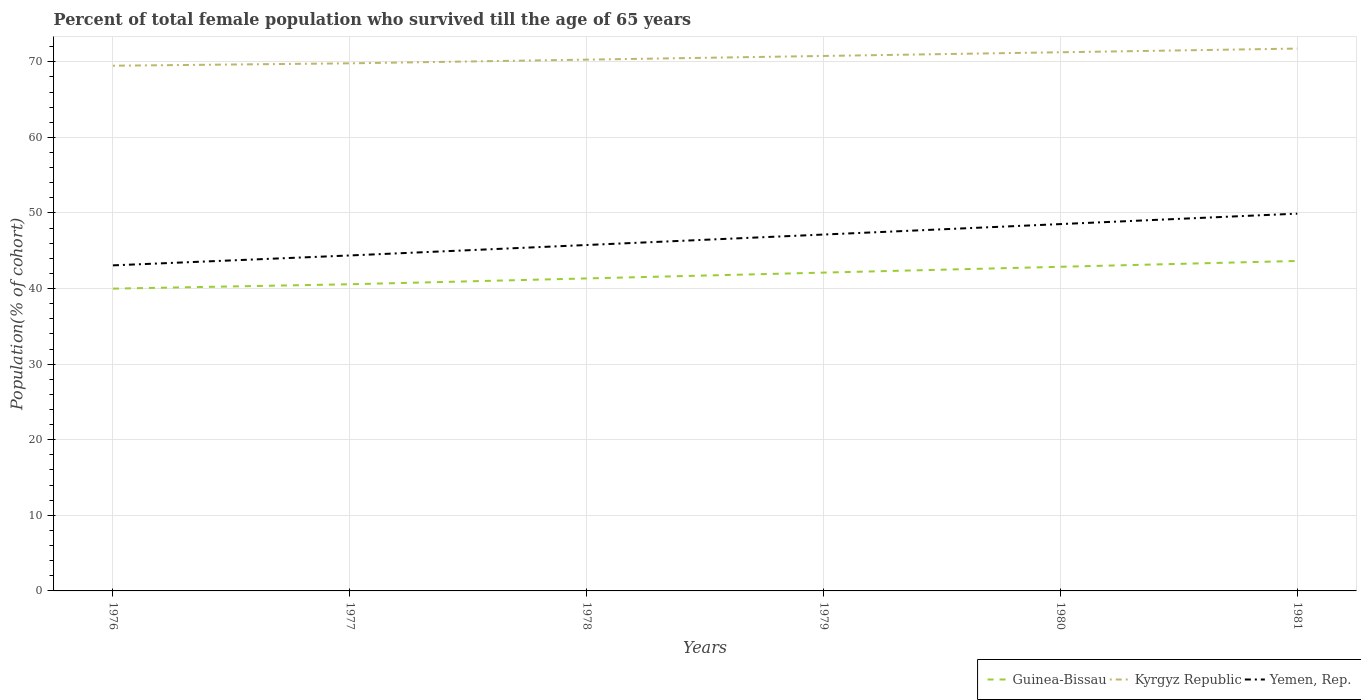Does the line corresponding to Kyrgyz Republic intersect with the line corresponding to Guinea-Bissau?
Offer a very short reply. No. Is the number of lines equal to the number of legend labels?
Offer a terse response. Yes. Across all years, what is the maximum percentage of total female population who survived till the age of 65 years in Kyrgyz Republic?
Give a very brief answer. 69.48. In which year was the percentage of total female population who survived till the age of 65 years in Kyrgyz Republic maximum?
Your answer should be very brief. 1976. What is the total percentage of total female population who survived till the age of 65 years in Kyrgyz Republic in the graph?
Your answer should be very brief. -1.46. What is the difference between the highest and the second highest percentage of total female population who survived till the age of 65 years in Yemen, Rep.?
Make the answer very short. 6.84. How many lines are there?
Provide a succinct answer. 3. How many years are there in the graph?
Offer a very short reply. 6. What is the difference between two consecutive major ticks on the Y-axis?
Your answer should be very brief. 10. Does the graph contain grids?
Offer a terse response. Yes. How many legend labels are there?
Offer a very short reply. 3. What is the title of the graph?
Make the answer very short. Percent of total female population who survived till the age of 65 years. Does "Low & middle income" appear as one of the legend labels in the graph?
Make the answer very short. No. What is the label or title of the Y-axis?
Offer a terse response. Population(% of cohort). What is the Population(% of cohort) of Guinea-Bissau in 1976?
Make the answer very short. 39.99. What is the Population(% of cohort) in Kyrgyz Republic in 1976?
Ensure brevity in your answer.  69.48. What is the Population(% of cohort) of Yemen, Rep. in 1976?
Your response must be concise. 43.07. What is the Population(% of cohort) of Guinea-Bissau in 1977?
Offer a very short reply. 40.57. What is the Population(% of cohort) of Kyrgyz Republic in 1977?
Your response must be concise. 69.8. What is the Population(% of cohort) of Yemen, Rep. in 1977?
Offer a terse response. 44.38. What is the Population(% of cohort) of Guinea-Bissau in 1978?
Keep it short and to the point. 41.34. What is the Population(% of cohort) in Kyrgyz Republic in 1978?
Give a very brief answer. 70.29. What is the Population(% of cohort) of Yemen, Rep. in 1978?
Offer a terse response. 45.76. What is the Population(% of cohort) in Guinea-Bissau in 1979?
Your answer should be very brief. 42.11. What is the Population(% of cohort) in Kyrgyz Republic in 1979?
Ensure brevity in your answer.  70.77. What is the Population(% of cohort) in Yemen, Rep. in 1979?
Give a very brief answer. 47.15. What is the Population(% of cohort) in Guinea-Bissau in 1980?
Give a very brief answer. 42.88. What is the Population(% of cohort) in Kyrgyz Republic in 1980?
Offer a terse response. 71.26. What is the Population(% of cohort) of Yemen, Rep. in 1980?
Offer a terse response. 48.53. What is the Population(% of cohort) in Guinea-Bissau in 1981?
Provide a succinct answer. 43.65. What is the Population(% of cohort) in Kyrgyz Republic in 1981?
Provide a short and direct response. 71.75. What is the Population(% of cohort) of Yemen, Rep. in 1981?
Your response must be concise. 49.91. Across all years, what is the maximum Population(% of cohort) of Guinea-Bissau?
Offer a terse response. 43.65. Across all years, what is the maximum Population(% of cohort) of Kyrgyz Republic?
Your answer should be very brief. 71.75. Across all years, what is the maximum Population(% of cohort) of Yemen, Rep.?
Your answer should be very brief. 49.91. Across all years, what is the minimum Population(% of cohort) of Guinea-Bissau?
Provide a succinct answer. 39.99. Across all years, what is the minimum Population(% of cohort) of Kyrgyz Republic?
Give a very brief answer. 69.48. Across all years, what is the minimum Population(% of cohort) of Yemen, Rep.?
Make the answer very short. 43.07. What is the total Population(% of cohort) in Guinea-Bissau in the graph?
Provide a succinct answer. 250.54. What is the total Population(% of cohort) in Kyrgyz Republic in the graph?
Provide a succinct answer. 423.35. What is the total Population(% of cohort) in Yemen, Rep. in the graph?
Ensure brevity in your answer.  278.8. What is the difference between the Population(% of cohort) of Guinea-Bissau in 1976 and that in 1977?
Ensure brevity in your answer.  -0.58. What is the difference between the Population(% of cohort) of Kyrgyz Republic in 1976 and that in 1977?
Offer a terse response. -0.32. What is the difference between the Population(% of cohort) in Yemen, Rep. in 1976 and that in 1977?
Make the answer very short. -1.31. What is the difference between the Population(% of cohort) in Guinea-Bissau in 1976 and that in 1978?
Your answer should be very brief. -1.35. What is the difference between the Population(% of cohort) in Kyrgyz Republic in 1976 and that in 1978?
Provide a short and direct response. -0.8. What is the difference between the Population(% of cohort) of Yemen, Rep. in 1976 and that in 1978?
Provide a short and direct response. -2.69. What is the difference between the Population(% of cohort) of Guinea-Bissau in 1976 and that in 1979?
Your answer should be compact. -2.12. What is the difference between the Population(% of cohort) of Kyrgyz Republic in 1976 and that in 1979?
Give a very brief answer. -1.29. What is the difference between the Population(% of cohort) in Yemen, Rep. in 1976 and that in 1979?
Ensure brevity in your answer.  -4.08. What is the difference between the Population(% of cohort) of Guinea-Bissau in 1976 and that in 1980?
Give a very brief answer. -2.89. What is the difference between the Population(% of cohort) of Kyrgyz Republic in 1976 and that in 1980?
Provide a succinct answer. -1.78. What is the difference between the Population(% of cohort) in Yemen, Rep. in 1976 and that in 1980?
Your answer should be very brief. -5.46. What is the difference between the Population(% of cohort) of Guinea-Bissau in 1976 and that in 1981?
Offer a very short reply. -3.66. What is the difference between the Population(% of cohort) of Kyrgyz Republic in 1976 and that in 1981?
Offer a terse response. -2.27. What is the difference between the Population(% of cohort) of Yemen, Rep. in 1976 and that in 1981?
Offer a very short reply. -6.84. What is the difference between the Population(% of cohort) of Guinea-Bissau in 1977 and that in 1978?
Your response must be concise. -0.77. What is the difference between the Population(% of cohort) of Kyrgyz Republic in 1977 and that in 1978?
Offer a very short reply. -0.49. What is the difference between the Population(% of cohort) of Yemen, Rep. in 1977 and that in 1978?
Provide a succinct answer. -1.38. What is the difference between the Population(% of cohort) in Guinea-Bissau in 1977 and that in 1979?
Provide a succinct answer. -1.54. What is the difference between the Population(% of cohort) in Kyrgyz Republic in 1977 and that in 1979?
Your response must be concise. -0.98. What is the difference between the Population(% of cohort) in Yemen, Rep. in 1977 and that in 1979?
Your answer should be very brief. -2.77. What is the difference between the Population(% of cohort) in Guinea-Bissau in 1977 and that in 1980?
Give a very brief answer. -2.31. What is the difference between the Population(% of cohort) of Kyrgyz Republic in 1977 and that in 1980?
Offer a terse response. -1.46. What is the difference between the Population(% of cohort) in Yemen, Rep. in 1977 and that in 1980?
Provide a short and direct response. -4.15. What is the difference between the Population(% of cohort) of Guinea-Bissau in 1977 and that in 1981?
Offer a terse response. -3.08. What is the difference between the Population(% of cohort) in Kyrgyz Republic in 1977 and that in 1981?
Your answer should be compact. -1.95. What is the difference between the Population(% of cohort) in Yemen, Rep. in 1977 and that in 1981?
Provide a succinct answer. -5.53. What is the difference between the Population(% of cohort) in Guinea-Bissau in 1978 and that in 1979?
Give a very brief answer. -0.77. What is the difference between the Population(% of cohort) of Kyrgyz Republic in 1978 and that in 1979?
Offer a terse response. -0.49. What is the difference between the Population(% of cohort) of Yemen, Rep. in 1978 and that in 1979?
Keep it short and to the point. -1.38. What is the difference between the Population(% of cohort) of Guinea-Bissau in 1978 and that in 1980?
Your answer should be very brief. -1.54. What is the difference between the Population(% of cohort) in Kyrgyz Republic in 1978 and that in 1980?
Provide a short and direct response. -0.98. What is the difference between the Population(% of cohort) in Yemen, Rep. in 1978 and that in 1980?
Offer a terse response. -2.77. What is the difference between the Population(% of cohort) in Guinea-Bissau in 1978 and that in 1981?
Give a very brief answer. -2.31. What is the difference between the Population(% of cohort) in Kyrgyz Republic in 1978 and that in 1981?
Ensure brevity in your answer.  -1.46. What is the difference between the Population(% of cohort) in Yemen, Rep. in 1978 and that in 1981?
Keep it short and to the point. -4.15. What is the difference between the Population(% of cohort) of Guinea-Bissau in 1979 and that in 1980?
Your response must be concise. -0.77. What is the difference between the Population(% of cohort) of Kyrgyz Republic in 1979 and that in 1980?
Your answer should be compact. -0.49. What is the difference between the Population(% of cohort) of Yemen, Rep. in 1979 and that in 1980?
Provide a short and direct response. -1.38. What is the difference between the Population(% of cohort) of Guinea-Bissau in 1979 and that in 1981?
Provide a succinct answer. -1.54. What is the difference between the Population(% of cohort) in Kyrgyz Republic in 1979 and that in 1981?
Your answer should be very brief. -0.98. What is the difference between the Population(% of cohort) of Yemen, Rep. in 1979 and that in 1981?
Provide a succinct answer. -2.77. What is the difference between the Population(% of cohort) of Guinea-Bissau in 1980 and that in 1981?
Keep it short and to the point. -0.77. What is the difference between the Population(% of cohort) in Kyrgyz Republic in 1980 and that in 1981?
Offer a terse response. -0.49. What is the difference between the Population(% of cohort) of Yemen, Rep. in 1980 and that in 1981?
Provide a short and direct response. -1.38. What is the difference between the Population(% of cohort) in Guinea-Bissau in 1976 and the Population(% of cohort) in Kyrgyz Republic in 1977?
Offer a very short reply. -29.81. What is the difference between the Population(% of cohort) of Guinea-Bissau in 1976 and the Population(% of cohort) of Yemen, Rep. in 1977?
Offer a terse response. -4.39. What is the difference between the Population(% of cohort) of Kyrgyz Republic in 1976 and the Population(% of cohort) of Yemen, Rep. in 1977?
Ensure brevity in your answer.  25.1. What is the difference between the Population(% of cohort) in Guinea-Bissau in 1976 and the Population(% of cohort) in Kyrgyz Republic in 1978?
Offer a very short reply. -30.3. What is the difference between the Population(% of cohort) in Guinea-Bissau in 1976 and the Population(% of cohort) in Yemen, Rep. in 1978?
Ensure brevity in your answer.  -5.77. What is the difference between the Population(% of cohort) in Kyrgyz Republic in 1976 and the Population(% of cohort) in Yemen, Rep. in 1978?
Give a very brief answer. 23.72. What is the difference between the Population(% of cohort) of Guinea-Bissau in 1976 and the Population(% of cohort) of Kyrgyz Republic in 1979?
Keep it short and to the point. -30.78. What is the difference between the Population(% of cohort) in Guinea-Bissau in 1976 and the Population(% of cohort) in Yemen, Rep. in 1979?
Your answer should be compact. -7.16. What is the difference between the Population(% of cohort) in Kyrgyz Republic in 1976 and the Population(% of cohort) in Yemen, Rep. in 1979?
Offer a terse response. 22.33. What is the difference between the Population(% of cohort) of Guinea-Bissau in 1976 and the Population(% of cohort) of Kyrgyz Republic in 1980?
Provide a short and direct response. -31.27. What is the difference between the Population(% of cohort) of Guinea-Bissau in 1976 and the Population(% of cohort) of Yemen, Rep. in 1980?
Your answer should be compact. -8.54. What is the difference between the Population(% of cohort) of Kyrgyz Republic in 1976 and the Population(% of cohort) of Yemen, Rep. in 1980?
Provide a short and direct response. 20.95. What is the difference between the Population(% of cohort) of Guinea-Bissau in 1976 and the Population(% of cohort) of Kyrgyz Republic in 1981?
Give a very brief answer. -31.76. What is the difference between the Population(% of cohort) of Guinea-Bissau in 1976 and the Population(% of cohort) of Yemen, Rep. in 1981?
Your answer should be compact. -9.92. What is the difference between the Population(% of cohort) in Kyrgyz Republic in 1976 and the Population(% of cohort) in Yemen, Rep. in 1981?
Your answer should be compact. 19.57. What is the difference between the Population(% of cohort) of Guinea-Bissau in 1977 and the Population(% of cohort) of Kyrgyz Republic in 1978?
Keep it short and to the point. -29.72. What is the difference between the Population(% of cohort) in Guinea-Bissau in 1977 and the Population(% of cohort) in Yemen, Rep. in 1978?
Keep it short and to the point. -5.19. What is the difference between the Population(% of cohort) of Kyrgyz Republic in 1977 and the Population(% of cohort) of Yemen, Rep. in 1978?
Keep it short and to the point. 24.03. What is the difference between the Population(% of cohort) of Guinea-Bissau in 1977 and the Population(% of cohort) of Kyrgyz Republic in 1979?
Provide a short and direct response. -30.2. What is the difference between the Population(% of cohort) in Guinea-Bissau in 1977 and the Population(% of cohort) in Yemen, Rep. in 1979?
Give a very brief answer. -6.58. What is the difference between the Population(% of cohort) of Kyrgyz Republic in 1977 and the Population(% of cohort) of Yemen, Rep. in 1979?
Offer a terse response. 22.65. What is the difference between the Population(% of cohort) in Guinea-Bissau in 1977 and the Population(% of cohort) in Kyrgyz Republic in 1980?
Offer a terse response. -30.69. What is the difference between the Population(% of cohort) of Guinea-Bissau in 1977 and the Population(% of cohort) of Yemen, Rep. in 1980?
Your response must be concise. -7.96. What is the difference between the Population(% of cohort) of Kyrgyz Republic in 1977 and the Population(% of cohort) of Yemen, Rep. in 1980?
Provide a short and direct response. 21.27. What is the difference between the Population(% of cohort) in Guinea-Bissau in 1977 and the Population(% of cohort) in Kyrgyz Republic in 1981?
Offer a very short reply. -31.18. What is the difference between the Population(% of cohort) of Guinea-Bissau in 1977 and the Population(% of cohort) of Yemen, Rep. in 1981?
Provide a short and direct response. -9.34. What is the difference between the Population(% of cohort) of Kyrgyz Republic in 1977 and the Population(% of cohort) of Yemen, Rep. in 1981?
Keep it short and to the point. 19.89. What is the difference between the Population(% of cohort) of Guinea-Bissau in 1978 and the Population(% of cohort) of Kyrgyz Republic in 1979?
Offer a very short reply. -29.43. What is the difference between the Population(% of cohort) of Guinea-Bissau in 1978 and the Population(% of cohort) of Yemen, Rep. in 1979?
Make the answer very short. -5.81. What is the difference between the Population(% of cohort) in Kyrgyz Republic in 1978 and the Population(% of cohort) in Yemen, Rep. in 1979?
Keep it short and to the point. 23.14. What is the difference between the Population(% of cohort) of Guinea-Bissau in 1978 and the Population(% of cohort) of Kyrgyz Republic in 1980?
Give a very brief answer. -29.92. What is the difference between the Population(% of cohort) of Guinea-Bissau in 1978 and the Population(% of cohort) of Yemen, Rep. in 1980?
Offer a very short reply. -7.19. What is the difference between the Population(% of cohort) in Kyrgyz Republic in 1978 and the Population(% of cohort) in Yemen, Rep. in 1980?
Keep it short and to the point. 21.76. What is the difference between the Population(% of cohort) in Guinea-Bissau in 1978 and the Population(% of cohort) in Kyrgyz Republic in 1981?
Provide a short and direct response. -30.41. What is the difference between the Population(% of cohort) of Guinea-Bissau in 1978 and the Population(% of cohort) of Yemen, Rep. in 1981?
Your response must be concise. -8.57. What is the difference between the Population(% of cohort) of Kyrgyz Republic in 1978 and the Population(% of cohort) of Yemen, Rep. in 1981?
Offer a terse response. 20.37. What is the difference between the Population(% of cohort) in Guinea-Bissau in 1979 and the Population(% of cohort) in Kyrgyz Republic in 1980?
Provide a short and direct response. -29.15. What is the difference between the Population(% of cohort) in Guinea-Bissau in 1979 and the Population(% of cohort) in Yemen, Rep. in 1980?
Keep it short and to the point. -6.42. What is the difference between the Population(% of cohort) in Kyrgyz Republic in 1979 and the Population(% of cohort) in Yemen, Rep. in 1980?
Your answer should be very brief. 22.24. What is the difference between the Population(% of cohort) of Guinea-Bissau in 1979 and the Population(% of cohort) of Kyrgyz Republic in 1981?
Make the answer very short. -29.64. What is the difference between the Population(% of cohort) in Guinea-Bissau in 1979 and the Population(% of cohort) in Yemen, Rep. in 1981?
Your answer should be compact. -7.8. What is the difference between the Population(% of cohort) of Kyrgyz Republic in 1979 and the Population(% of cohort) of Yemen, Rep. in 1981?
Your response must be concise. 20.86. What is the difference between the Population(% of cohort) of Guinea-Bissau in 1980 and the Population(% of cohort) of Kyrgyz Republic in 1981?
Ensure brevity in your answer.  -28.87. What is the difference between the Population(% of cohort) of Guinea-Bissau in 1980 and the Population(% of cohort) of Yemen, Rep. in 1981?
Make the answer very short. -7.03. What is the difference between the Population(% of cohort) of Kyrgyz Republic in 1980 and the Population(% of cohort) of Yemen, Rep. in 1981?
Make the answer very short. 21.35. What is the average Population(% of cohort) in Guinea-Bissau per year?
Ensure brevity in your answer.  41.76. What is the average Population(% of cohort) of Kyrgyz Republic per year?
Keep it short and to the point. 70.56. What is the average Population(% of cohort) of Yemen, Rep. per year?
Your response must be concise. 46.47. In the year 1976, what is the difference between the Population(% of cohort) in Guinea-Bissau and Population(% of cohort) in Kyrgyz Republic?
Provide a short and direct response. -29.49. In the year 1976, what is the difference between the Population(% of cohort) of Guinea-Bissau and Population(% of cohort) of Yemen, Rep.?
Ensure brevity in your answer.  -3.08. In the year 1976, what is the difference between the Population(% of cohort) in Kyrgyz Republic and Population(% of cohort) in Yemen, Rep.?
Your answer should be very brief. 26.41. In the year 1977, what is the difference between the Population(% of cohort) in Guinea-Bissau and Population(% of cohort) in Kyrgyz Republic?
Keep it short and to the point. -29.23. In the year 1977, what is the difference between the Population(% of cohort) of Guinea-Bissau and Population(% of cohort) of Yemen, Rep.?
Make the answer very short. -3.81. In the year 1977, what is the difference between the Population(% of cohort) of Kyrgyz Republic and Population(% of cohort) of Yemen, Rep.?
Keep it short and to the point. 25.42. In the year 1978, what is the difference between the Population(% of cohort) of Guinea-Bissau and Population(% of cohort) of Kyrgyz Republic?
Offer a terse response. -28.95. In the year 1978, what is the difference between the Population(% of cohort) of Guinea-Bissau and Population(% of cohort) of Yemen, Rep.?
Offer a very short reply. -4.42. In the year 1978, what is the difference between the Population(% of cohort) in Kyrgyz Republic and Population(% of cohort) in Yemen, Rep.?
Your answer should be very brief. 24.52. In the year 1979, what is the difference between the Population(% of cohort) of Guinea-Bissau and Population(% of cohort) of Kyrgyz Republic?
Give a very brief answer. -28.66. In the year 1979, what is the difference between the Population(% of cohort) of Guinea-Bissau and Population(% of cohort) of Yemen, Rep.?
Your answer should be compact. -5.04. In the year 1979, what is the difference between the Population(% of cohort) of Kyrgyz Republic and Population(% of cohort) of Yemen, Rep.?
Offer a very short reply. 23.63. In the year 1980, what is the difference between the Population(% of cohort) of Guinea-Bissau and Population(% of cohort) of Kyrgyz Republic?
Your answer should be very brief. -28.38. In the year 1980, what is the difference between the Population(% of cohort) of Guinea-Bissau and Population(% of cohort) of Yemen, Rep.?
Provide a succinct answer. -5.65. In the year 1980, what is the difference between the Population(% of cohort) of Kyrgyz Republic and Population(% of cohort) of Yemen, Rep.?
Ensure brevity in your answer.  22.73. In the year 1981, what is the difference between the Population(% of cohort) in Guinea-Bissau and Population(% of cohort) in Kyrgyz Republic?
Ensure brevity in your answer.  -28.1. In the year 1981, what is the difference between the Population(% of cohort) of Guinea-Bissau and Population(% of cohort) of Yemen, Rep.?
Make the answer very short. -6.26. In the year 1981, what is the difference between the Population(% of cohort) in Kyrgyz Republic and Population(% of cohort) in Yemen, Rep.?
Your answer should be very brief. 21.84. What is the ratio of the Population(% of cohort) in Guinea-Bissau in 1976 to that in 1977?
Keep it short and to the point. 0.99. What is the ratio of the Population(% of cohort) of Yemen, Rep. in 1976 to that in 1977?
Give a very brief answer. 0.97. What is the ratio of the Population(% of cohort) of Guinea-Bissau in 1976 to that in 1978?
Offer a very short reply. 0.97. What is the ratio of the Population(% of cohort) in Yemen, Rep. in 1976 to that in 1978?
Your response must be concise. 0.94. What is the ratio of the Population(% of cohort) of Guinea-Bissau in 1976 to that in 1979?
Your answer should be very brief. 0.95. What is the ratio of the Population(% of cohort) of Kyrgyz Republic in 1976 to that in 1979?
Your response must be concise. 0.98. What is the ratio of the Population(% of cohort) in Yemen, Rep. in 1976 to that in 1979?
Provide a succinct answer. 0.91. What is the ratio of the Population(% of cohort) in Guinea-Bissau in 1976 to that in 1980?
Provide a short and direct response. 0.93. What is the ratio of the Population(% of cohort) of Kyrgyz Republic in 1976 to that in 1980?
Your answer should be very brief. 0.97. What is the ratio of the Population(% of cohort) of Yemen, Rep. in 1976 to that in 1980?
Keep it short and to the point. 0.89. What is the ratio of the Population(% of cohort) in Guinea-Bissau in 1976 to that in 1981?
Give a very brief answer. 0.92. What is the ratio of the Population(% of cohort) in Kyrgyz Republic in 1976 to that in 1981?
Your response must be concise. 0.97. What is the ratio of the Population(% of cohort) in Yemen, Rep. in 1976 to that in 1981?
Your answer should be very brief. 0.86. What is the ratio of the Population(% of cohort) of Guinea-Bissau in 1977 to that in 1978?
Your response must be concise. 0.98. What is the ratio of the Population(% of cohort) in Yemen, Rep. in 1977 to that in 1978?
Keep it short and to the point. 0.97. What is the ratio of the Population(% of cohort) in Guinea-Bissau in 1977 to that in 1979?
Give a very brief answer. 0.96. What is the ratio of the Population(% of cohort) of Kyrgyz Republic in 1977 to that in 1979?
Give a very brief answer. 0.99. What is the ratio of the Population(% of cohort) of Yemen, Rep. in 1977 to that in 1979?
Give a very brief answer. 0.94. What is the ratio of the Population(% of cohort) of Guinea-Bissau in 1977 to that in 1980?
Offer a terse response. 0.95. What is the ratio of the Population(% of cohort) in Kyrgyz Republic in 1977 to that in 1980?
Provide a short and direct response. 0.98. What is the ratio of the Population(% of cohort) in Yemen, Rep. in 1977 to that in 1980?
Offer a terse response. 0.91. What is the ratio of the Population(% of cohort) in Guinea-Bissau in 1977 to that in 1981?
Give a very brief answer. 0.93. What is the ratio of the Population(% of cohort) of Kyrgyz Republic in 1977 to that in 1981?
Offer a very short reply. 0.97. What is the ratio of the Population(% of cohort) in Yemen, Rep. in 1977 to that in 1981?
Ensure brevity in your answer.  0.89. What is the ratio of the Population(% of cohort) of Guinea-Bissau in 1978 to that in 1979?
Give a very brief answer. 0.98. What is the ratio of the Population(% of cohort) in Kyrgyz Republic in 1978 to that in 1979?
Keep it short and to the point. 0.99. What is the ratio of the Population(% of cohort) of Yemen, Rep. in 1978 to that in 1979?
Make the answer very short. 0.97. What is the ratio of the Population(% of cohort) in Guinea-Bissau in 1978 to that in 1980?
Offer a terse response. 0.96. What is the ratio of the Population(% of cohort) in Kyrgyz Republic in 1978 to that in 1980?
Give a very brief answer. 0.99. What is the ratio of the Population(% of cohort) in Yemen, Rep. in 1978 to that in 1980?
Give a very brief answer. 0.94. What is the ratio of the Population(% of cohort) in Guinea-Bissau in 1978 to that in 1981?
Provide a succinct answer. 0.95. What is the ratio of the Population(% of cohort) in Kyrgyz Republic in 1978 to that in 1981?
Keep it short and to the point. 0.98. What is the ratio of the Population(% of cohort) in Yemen, Rep. in 1978 to that in 1981?
Make the answer very short. 0.92. What is the ratio of the Population(% of cohort) of Kyrgyz Republic in 1979 to that in 1980?
Your answer should be compact. 0.99. What is the ratio of the Population(% of cohort) in Yemen, Rep. in 1979 to that in 1980?
Provide a succinct answer. 0.97. What is the ratio of the Population(% of cohort) of Guinea-Bissau in 1979 to that in 1981?
Provide a succinct answer. 0.96. What is the ratio of the Population(% of cohort) of Kyrgyz Republic in 1979 to that in 1981?
Offer a terse response. 0.99. What is the ratio of the Population(% of cohort) in Yemen, Rep. in 1979 to that in 1981?
Give a very brief answer. 0.94. What is the ratio of the Population(% of cohort) of Guinea-Bissau in 1980 to that in 1981?
Make the answer very short. 0.98. What is the ratio of the Population(% of cohort) of Yemen, Rep. in 1980 to that in 1981?
Ensure brevity in your answer.  0.97. What is the difference between the highest and the second highest Population(% of cohort) in Guinea-Bissau?
Your answer should be very brief. 0.77. What is the difference between the highest and the second highest Population(% of cohort) of Kyrgyz Republic?
Make the answer very short. 0.49. What is the difference between the highest and the second highest Population(% of cohort) in Yemen, Rep.?
Make the answer very short. 1.38. What is the difference between the highest and the lowest Population(% of cohort) of Guinea-Bissau?
Offer a very short reply. 3.66. What is the difference between the highest and the lowest Population(% of cohort) of Kyrgyz Republic?
Offer a very short reply. 2.27. What is the difference between the highest and the lowest Population(% of cohort) in Yemen, Rep.?
Ensure brevity in your answer.  6.84. 